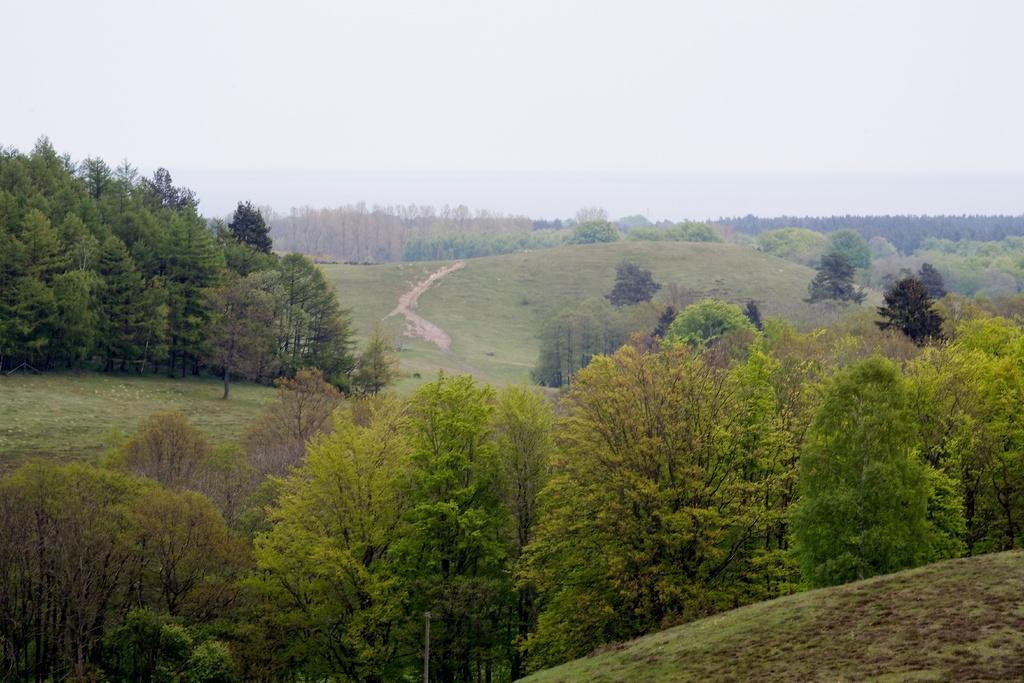In one or two sentences, can you explain what this image depicts? In this image I can see there are trees, at the top it is the sky. 